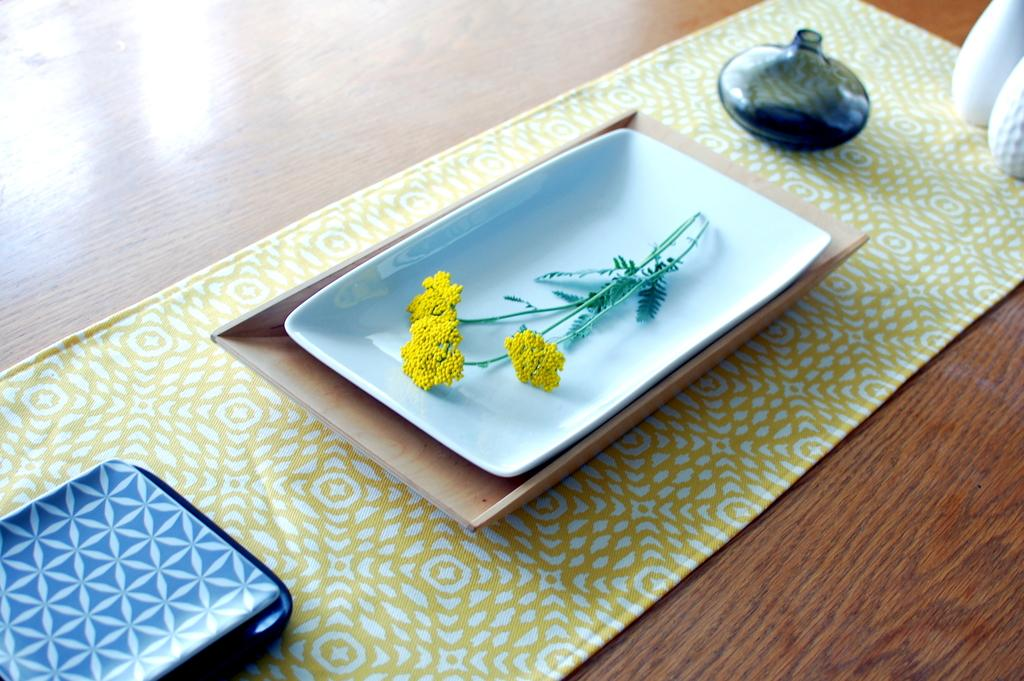What objects are present on a surface in the image? There are plates in the image. What type of plant is visible in the image? There is a flower in the image. What is on the floor in the image? There is a mat on the floor in the image. How many arches can be seen in the image? There are no arches present in the image. 